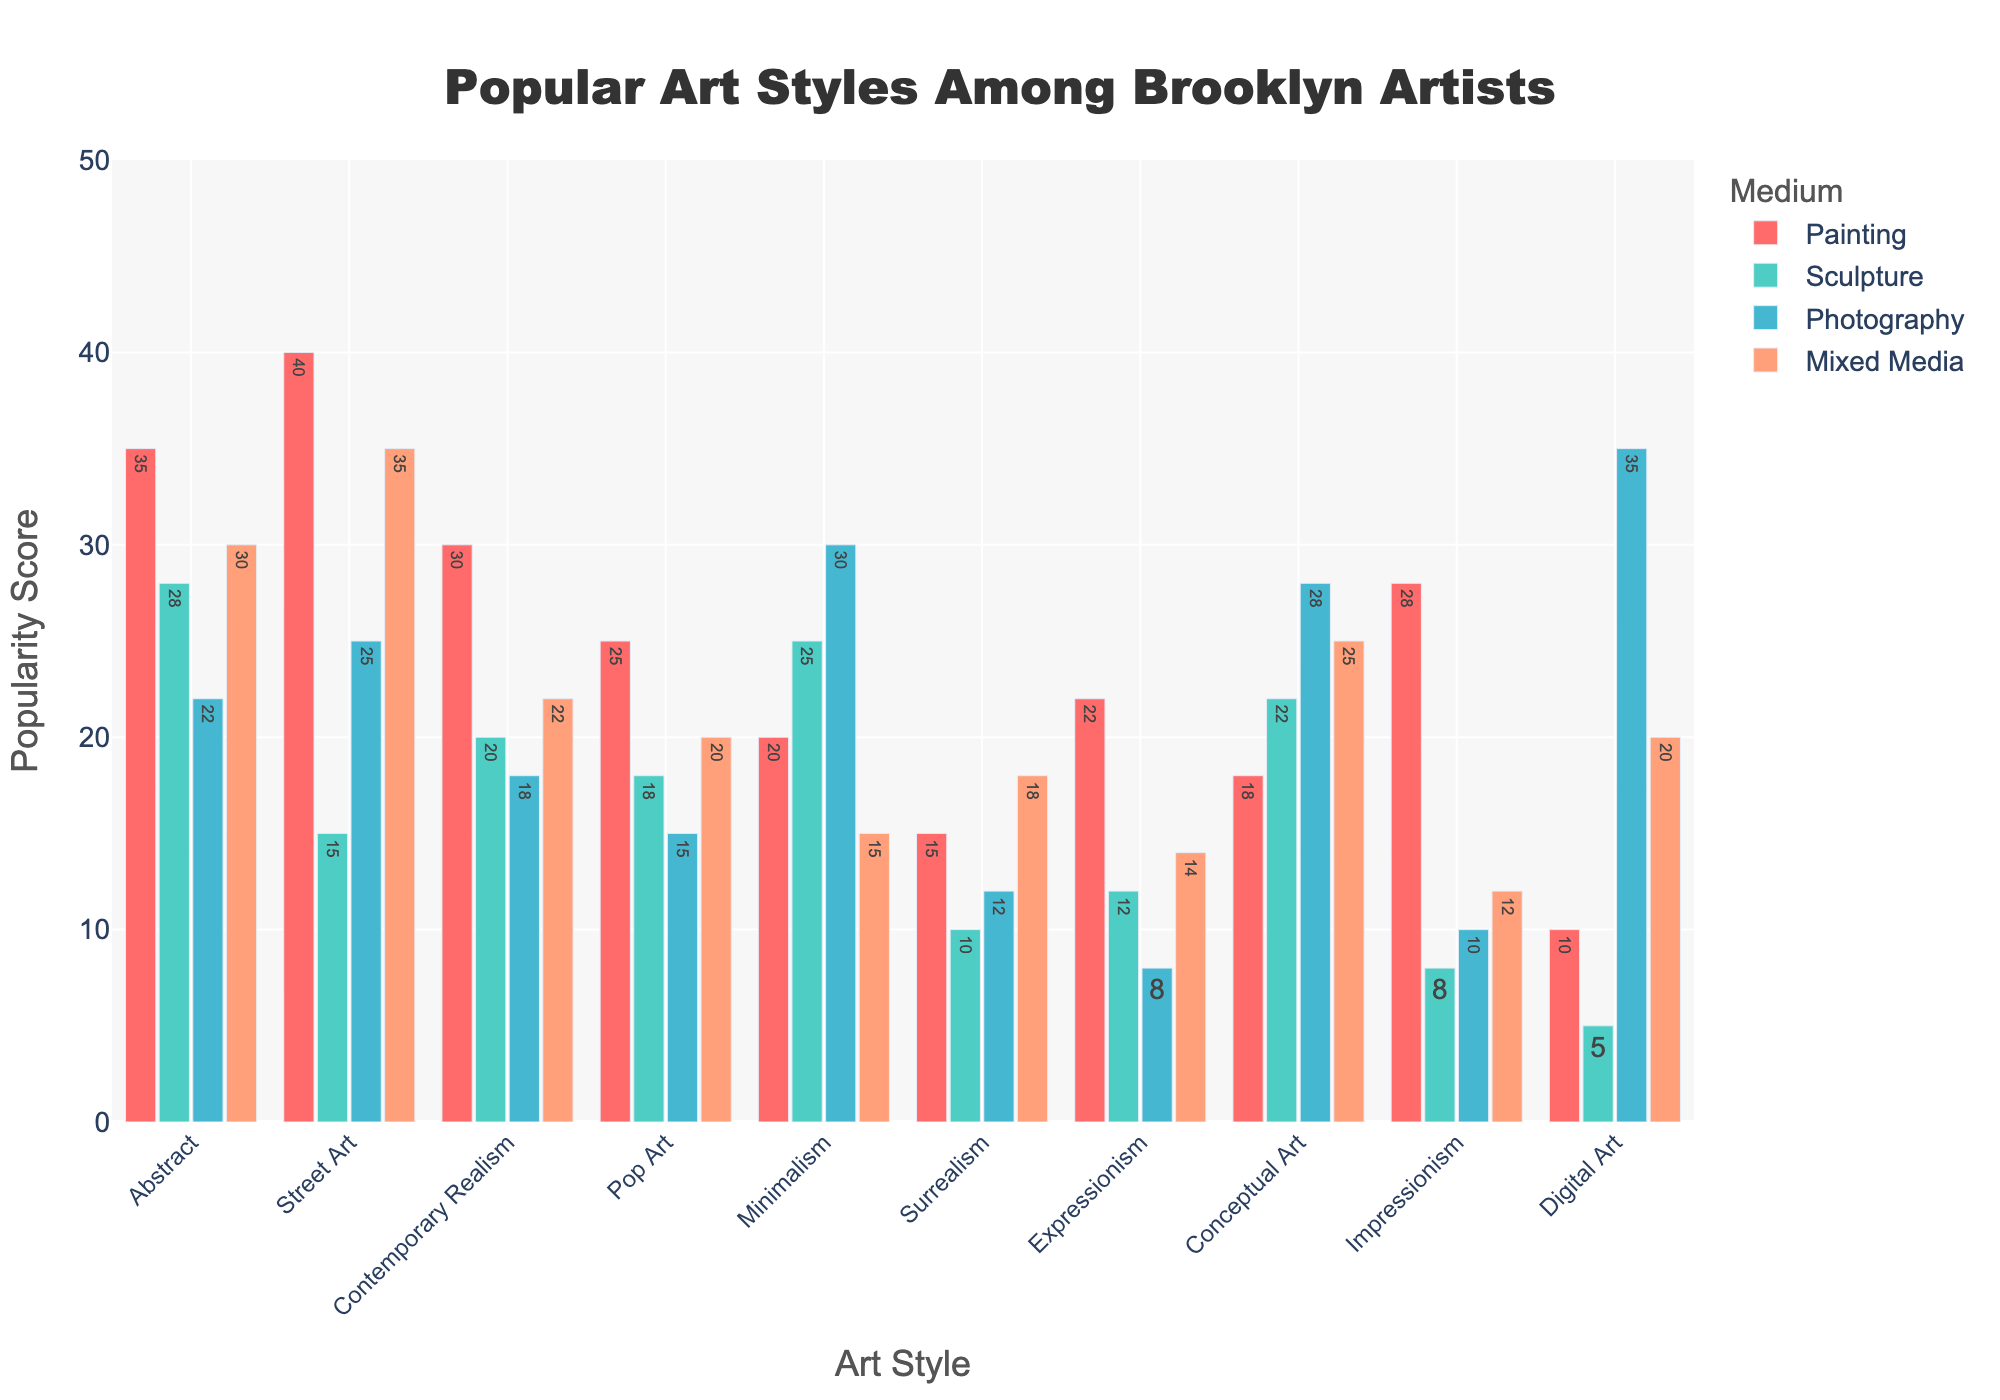What is the most popular art style among Brooklyn artists for the medium of Painting? The bar representing Painting for Street Art is the tallest among all art styles, indicating it has the highest value.
Answer: Street Art Which medium has the least popularity score for the art style Digital Art? The bar representing Sculpture for Digital Art has the smallest height among the four mediums, indicating it has the lowest value.
Answer: Sculpture How many more artists prefer Painting over Sculpture in the Abstract art style? The popularity score of Painting for Abstract is 35, and Sculpture is 28. Subtracting these two values gives the answer: 35 - 28 = 7.
Answer: 7 What is the total popularity score for the Contemporary Realism art style across all mediums? Summing up the values for Contemporary Realism across all mediums: Painting (30) + Sculpture (20) + Photography (18) + Mixed Media (22) = 90.
Answer: 90 Which art style has the highest popularity score for the medium of Photography? The bar representing Photography for Digital Art is the tallest among all art styles, indicating it has the highest value.
Answer: Digital Art For the art style Minimalism, is the popularity in Mixed Media more than Photography? The bar representing Mixed Media for Minimalism is shorter than the one for Photography, indicating Mixed Media has a lower value.
Answer: No Which art style has the smallest difference in popularity scores between the mediums Painting and Mixed Media? Calculate the differences for each art style: Abstract (35-30=5), Street Art (40-35=5), Contemporary Realism (30-22=8), Pop Art (25-20=5), Minimalism (20-15=5), Surrealism (15-18=3), Expressionism (22-14=8), Conceptual Art (18-25=7), Impressionism (28-12=16), Digital Art (10-20=10). Surrealism has the smallest difference.
Answer: Surrealism Compare the popularity score of Surrealism in Painting to Impressionism in Mixed Media. Which one is higher? The bar representing Painting for Surrealism (15) is shorter than the bar for Mixed Media in Impressionism (12+6), showing Surrealism in Painting has a higher value.
Answer: Surrealism in Painting What is the most popular medium for artists who favor Pop Art? The bar representing Paintings for Pop Art is the tallest among all mediums within that art style, indicating it has the highest value.
Answer: Painting 